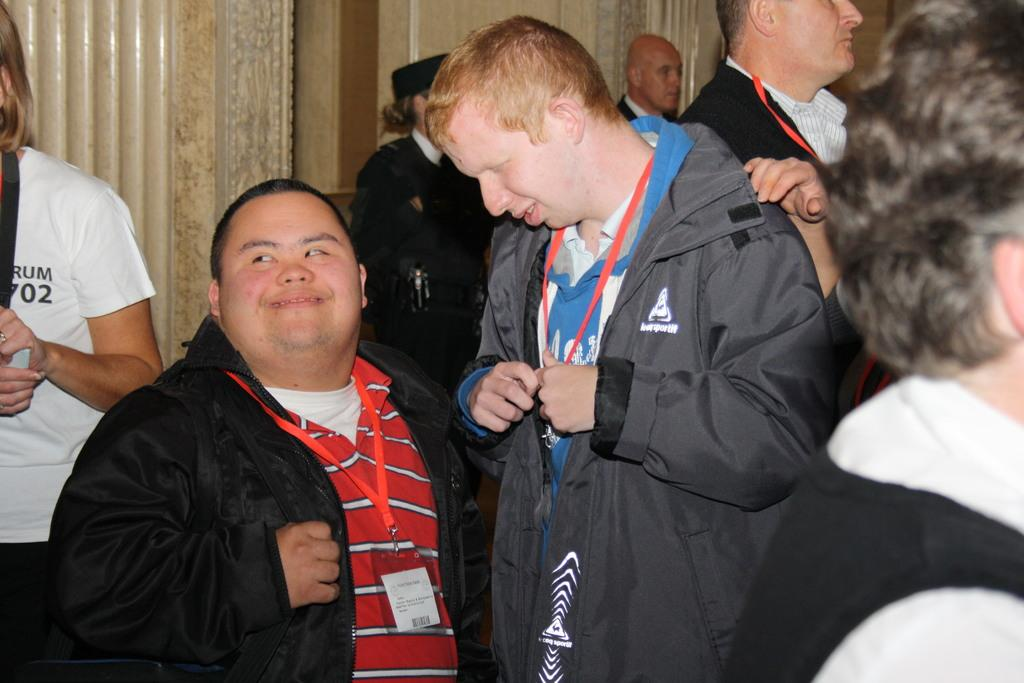What is happening in the image? There are people standing in the image. What are some of the people wearing? Some people are wearing coats. Are there any accessories visible on the people? Some people are wearing ID cards. What can be seen in the background of the image? There is a wall in the background of the image. How many sheep are visible in the image? There are no sheep present in the image. What type of skin is visible on the people in the image? The image does not show the skin of the people; it only shows them wearing coats and ID cards. 